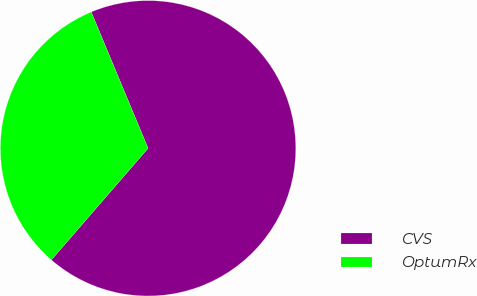Convert chart. <chart><loc_0><loc_0><loc_500><loc_500><pie_chart><fcel>CVS<fcel>OptumRx<nl><fcel>67.65%<fcel>32.35%<nl></chart> 